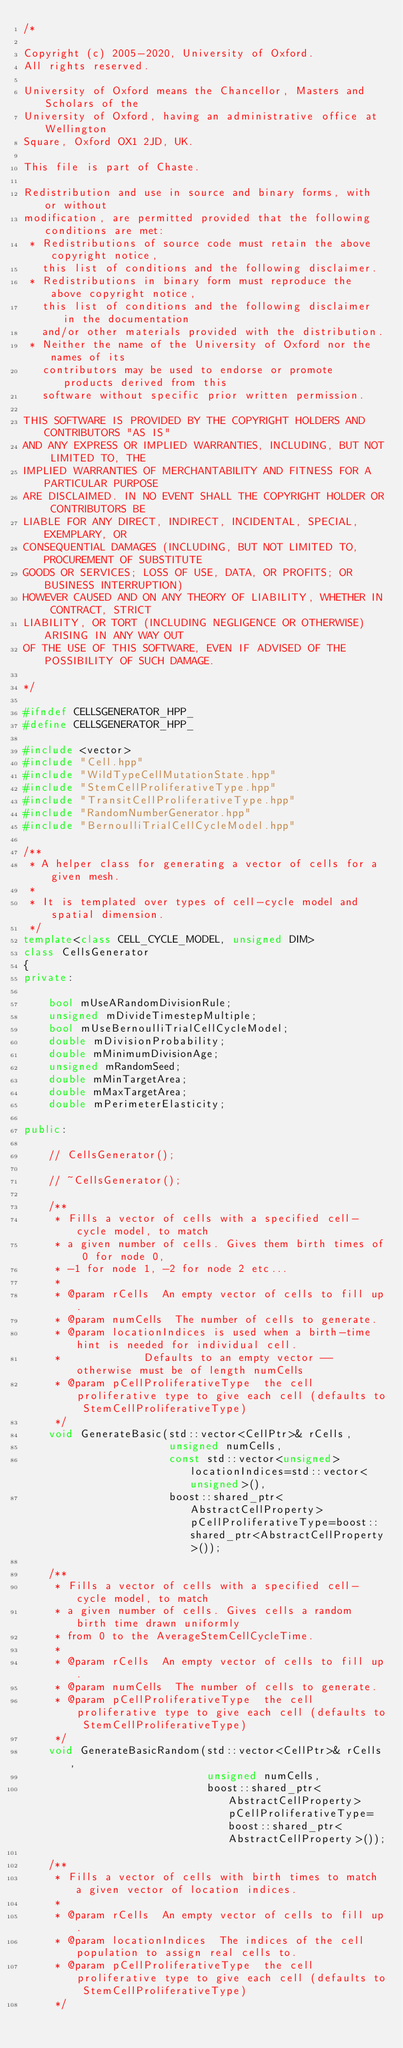Convert code to text. <code><loc_0><loc_0><loc_500><loc_500><_C++_>/*

Copyright (c) 2005-2020, University of Oxford.
All rights reserved.

University of Oxford means the Chancellor, Masters and Scholars of the
University of Oxford, having an administrative office at Wellington
Square, Oxford OX1 2JD, UK.

This file is part of Chaste.

Redistribution and use in source and binary forms, with or without
modification, are permitted provided that the following conditions are met:
 * Redistributions of source code must retain the above copyright notice,
   this list of conditions and the following disclaimer.
 * Redistributions in binary form must reproduce the above copyright notice,
   this list of conditions and the following disclaimer in the documentation
   and/or other materials provided with the distribution.
 * Neither the name of the University of Oxford nor the names of its
   contributors may be used to endorse or promote products derived from this
   software without specific prior written permission.

THIS SOFTWARE IS PROVIDED BY THE COPYRIGHT HOLDERS AND CONTRIBUTORS "AS IS"
AND ANY EXPRESS OR IMPLIED WARRANTIES, INCLUDING, BUT NOT LIMITED TO, THE
IMPLIED WARRANTIES OF MERCHANTABILITY AND FITNESS FOR A PARTICULAR PURPOSE
ARE DISCLAIMED. IN NO EVENT SHALL THE COPYRIGHT HOLDER OR CONTRIBUTORS BE
LIABLE FOR ANY DIRECT, INDIRECT, INCIDENTAL, SPECIAL, EXEMPLARY, OR
CONSEQUENTIAL DAMAGES (INCLUDING, BUT NOT LIMITED TO, PROCUREMENT OF SUBSTITUTE
GOODS OR SERVICES; LOSS OF USE, DATA, OR PROFITS; OR BUSINESS INTERRUPTION)
HOWEVER CAUSED AND ON ANY THEORY OF LIABILITY, WHETHER IN CONTRACT, STRICT
LIABILITY, OR TORT (INCLUDING NEGLIGENCE OR OTHERWISE) ARISING IN ANY WAY OUT
OF THE USE OF THIS SOFTWARE, EVEN IF ADVISED OF THE POSSIBILITY OF SUCH DAMAGE.

*/

#ifndef CELLSGENERATOR_HPP_
#define CELLSGENERATOR_HPP_

#include <vector>
#include "Cell.hpp"
#include "WildTypeCellMutationState.hpp"
#include "StemCellProliferativeType.hpp"
#include "TransitCellProliferativeType.hpp"
#include "RandomNumberGenerator.hpp"
#include "BernoulliTrialCellCycleModel.hpp"

/**
 * A helper class for generating a vector of cells for a given mesh.
 *
 * It is templated over types of cell-cycle model and spatial dimension.
 */
template<class CELL_CYCLE_MODEL, unsigned DIM>
class CellsGenerator
{
private:

    bool mUseARandomDivisionRule;
    unsigned mDivideTimestepMultiple;
    bool mUseBernoulliTrialCellCycleModel;
    double mDivisionProbability;
    double mMinimumDivisionAge;
    unsigned mRandomSeed;
    double mMinTargetArea;
    double mMaxTargetArea;
    double mPerimeterElasticity;

public:

    // CellsGenerator();

    // ~CellsGenerator();

    /**
     * Fills a vector of cells with a specified cell-cycle model, to match
     * a given number of cells. Gives them birth times of 0 for node 0,
     * -1 for node 1, -2 for node 2 etc...
     *
     * @param rCells  An empty vector of cells to fill up.
     * @param numCells  The number of cells to generate.
     * @param locationIndices is used when a birth-time hint is needed for individual cell.
     *             Defaults to an empty vector -- otherwise must be of length numCells
     * @param pCellProliferativeType  the cell proliferative type to give each cell (defaults to StemCellProliferativeType)
     */
    void GenerateBasic(std::vector<CellPtr>& rCells,
                       unsigned numCells,
                       const std::vector<unsigned> locationIndices=std::vector<unsigned>(),
                       boost::shared_ptr<AbstractCellProperty> pCellProliferativeType=boost::shared_ptr<AbstractCellProperty>());

    /**
     * Fills a vector of cells with a specified cell-cycle model, to match
     * a given number of cells. Gives cells a random birth time drawn uniformly
     * from 0 to the AverageStemCellCycleTime.
     *
     * @param rCells  An empty vector of cells to fill up.
     * @param numCells  The number of cells to generate.
     * @param pCellProliferativeType  the cell proliferative type to give each cell (defaults to StemCellProliferativeType)
     */
    void GenerateBasicRandom(std::vector<CellPtr>& rCells,
                             unsigned numCells,
                             boost::shared_ptr<AbstractCellProperty> pCellProliferativeType=boost::shared_ptr<AbstractCellProperty>());

    /**
     * Fills a vector of cells with birth times to match a given vector of location indices.
     *
     * @param rCells  An empty vector of cells to fill up.
     * @param locationIndices  The indices of the cell population to assign real cells to.
     * @param pCellProliferativeType  the cell proliferative type to give each cell (defaults to StemCellProliferativeType)
     */</code> 